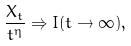<formula> <loc_0><loc_0><loc_500><loc_500>\frac { X _ { t } } { t ^ { \eta } } \Rightarrow I ( t \to \infty ) ,</formula> 